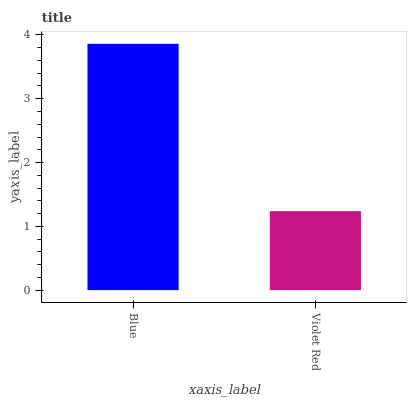Is Violet Red the maximum?
Answer yes or no. No. Is Blue greater than Violet Red?
Answer yes or no. Yes. Is Violet Red less than Blue?
Answer yes or no. Yes. Is Violet Red greater than Blue?
Answer yes or no. No. Is Blue less than Violet Red?
Answer yes or no. No. Is Blue the high median?
Answer yes or no. Yes. Is Violet Red the low median?
Answer yes or no. Yes. Is Violet Red the high median?
Answer yes or no. No. Is Blue the low median?
Answer yes or no. No. 